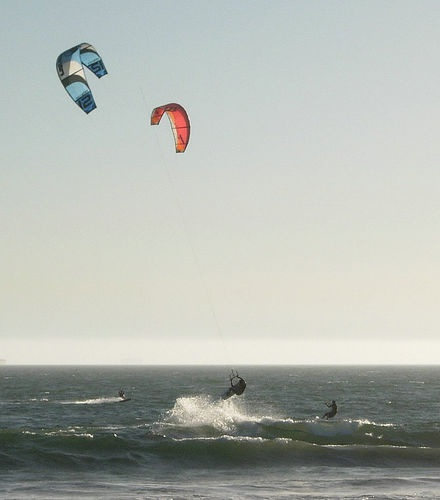Describe the objects in this image and their specific colors. I can see kite in lightblue, gray, blue, and darkgray tones, kite in lightblue, salmon, brown, and maroon tones, people in lightblue, black, gray, and darkgray tones, surfboard in lightblue, gray, black, and darkgray tones, and people in lightblue, black, and gray tones in this image. 